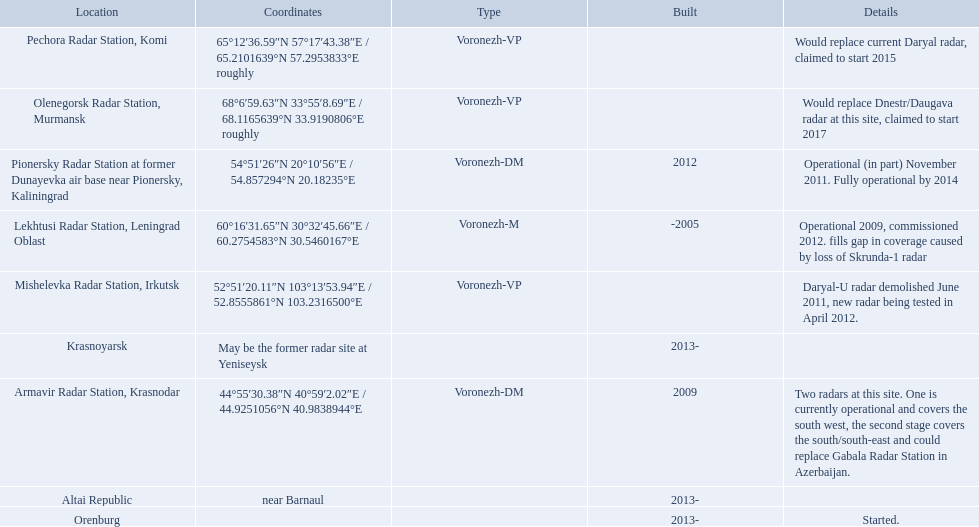Where is each radar? Lekhtusi Radar Station, Leningrad Oblast, Armavir Radar Station, Krasnodar, Pionersky Radar Station at former Dunayevka air base near Pionersky, Kaliningrad, Mishelevka Radar Station, Irkutsk, Pechora Radar Station, Komi, Olenegorsk Radar Station, Murmansk, Krasnoyarsk, Altai Republic, Orenburg. What are the details of each radar? Operational 2009, commissioned 2012. fills gap in coverage caused by loss of Skrunda-1 radar, Two radars at this site. One is currently operational and covers the south west, the second stage covers the south/south-east and could replace Gabala Radar Station in Azerbaijan., Operational (in part) November 2011. Fully operational by 2014, Daryal-U radar demolished June 2011, new radar being tested in April 2012., Would replace current Daryal radar, claimed to start 2015, Would replace Dnestr/Daugava radar at this site, claimed to start 2017, , , Started. Which radar is detailed to start in 2015? Pechora Radar Station, Komi. Which voronezh radar has already started? Orenburg. Which radar would replace dnestr/daugava? Olenegorsk Radar Station, Murmansk. Which radar started in 2015? Pechora Radar Station, Komi. 